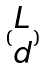Convert formula to latex. <formula><loc_0><loc_0><loc_500><loc_500>( \begin{matrix} L \\ d \end{matrix} )</formula> 